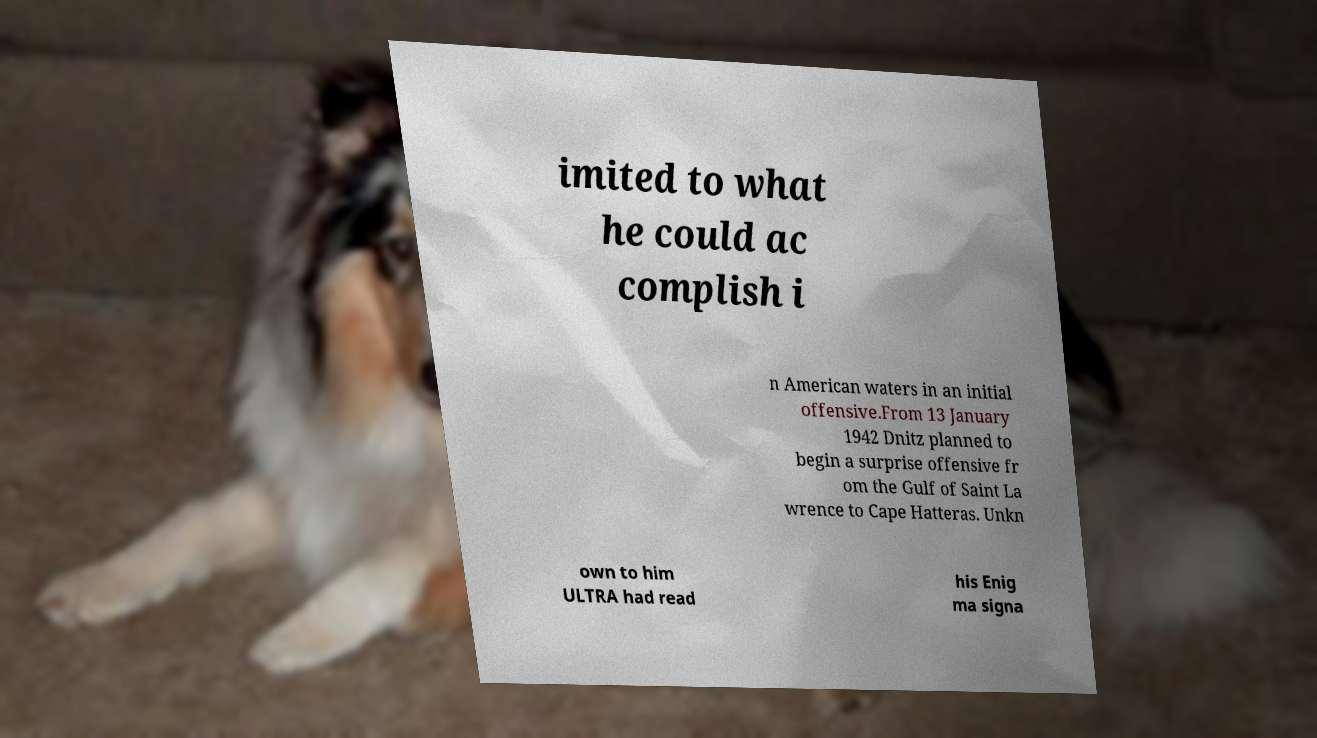Please identify and transcribe the text found in this image. imited to what he could ac complish i n American waters in an initial offensive.From 13 January 1942 Dnitz planned to begin a surprise offensive fr om the Gulf of Saint La wrence to Cape Hatteras. Unkn own to him ULTRA had read his Enig ma signa 